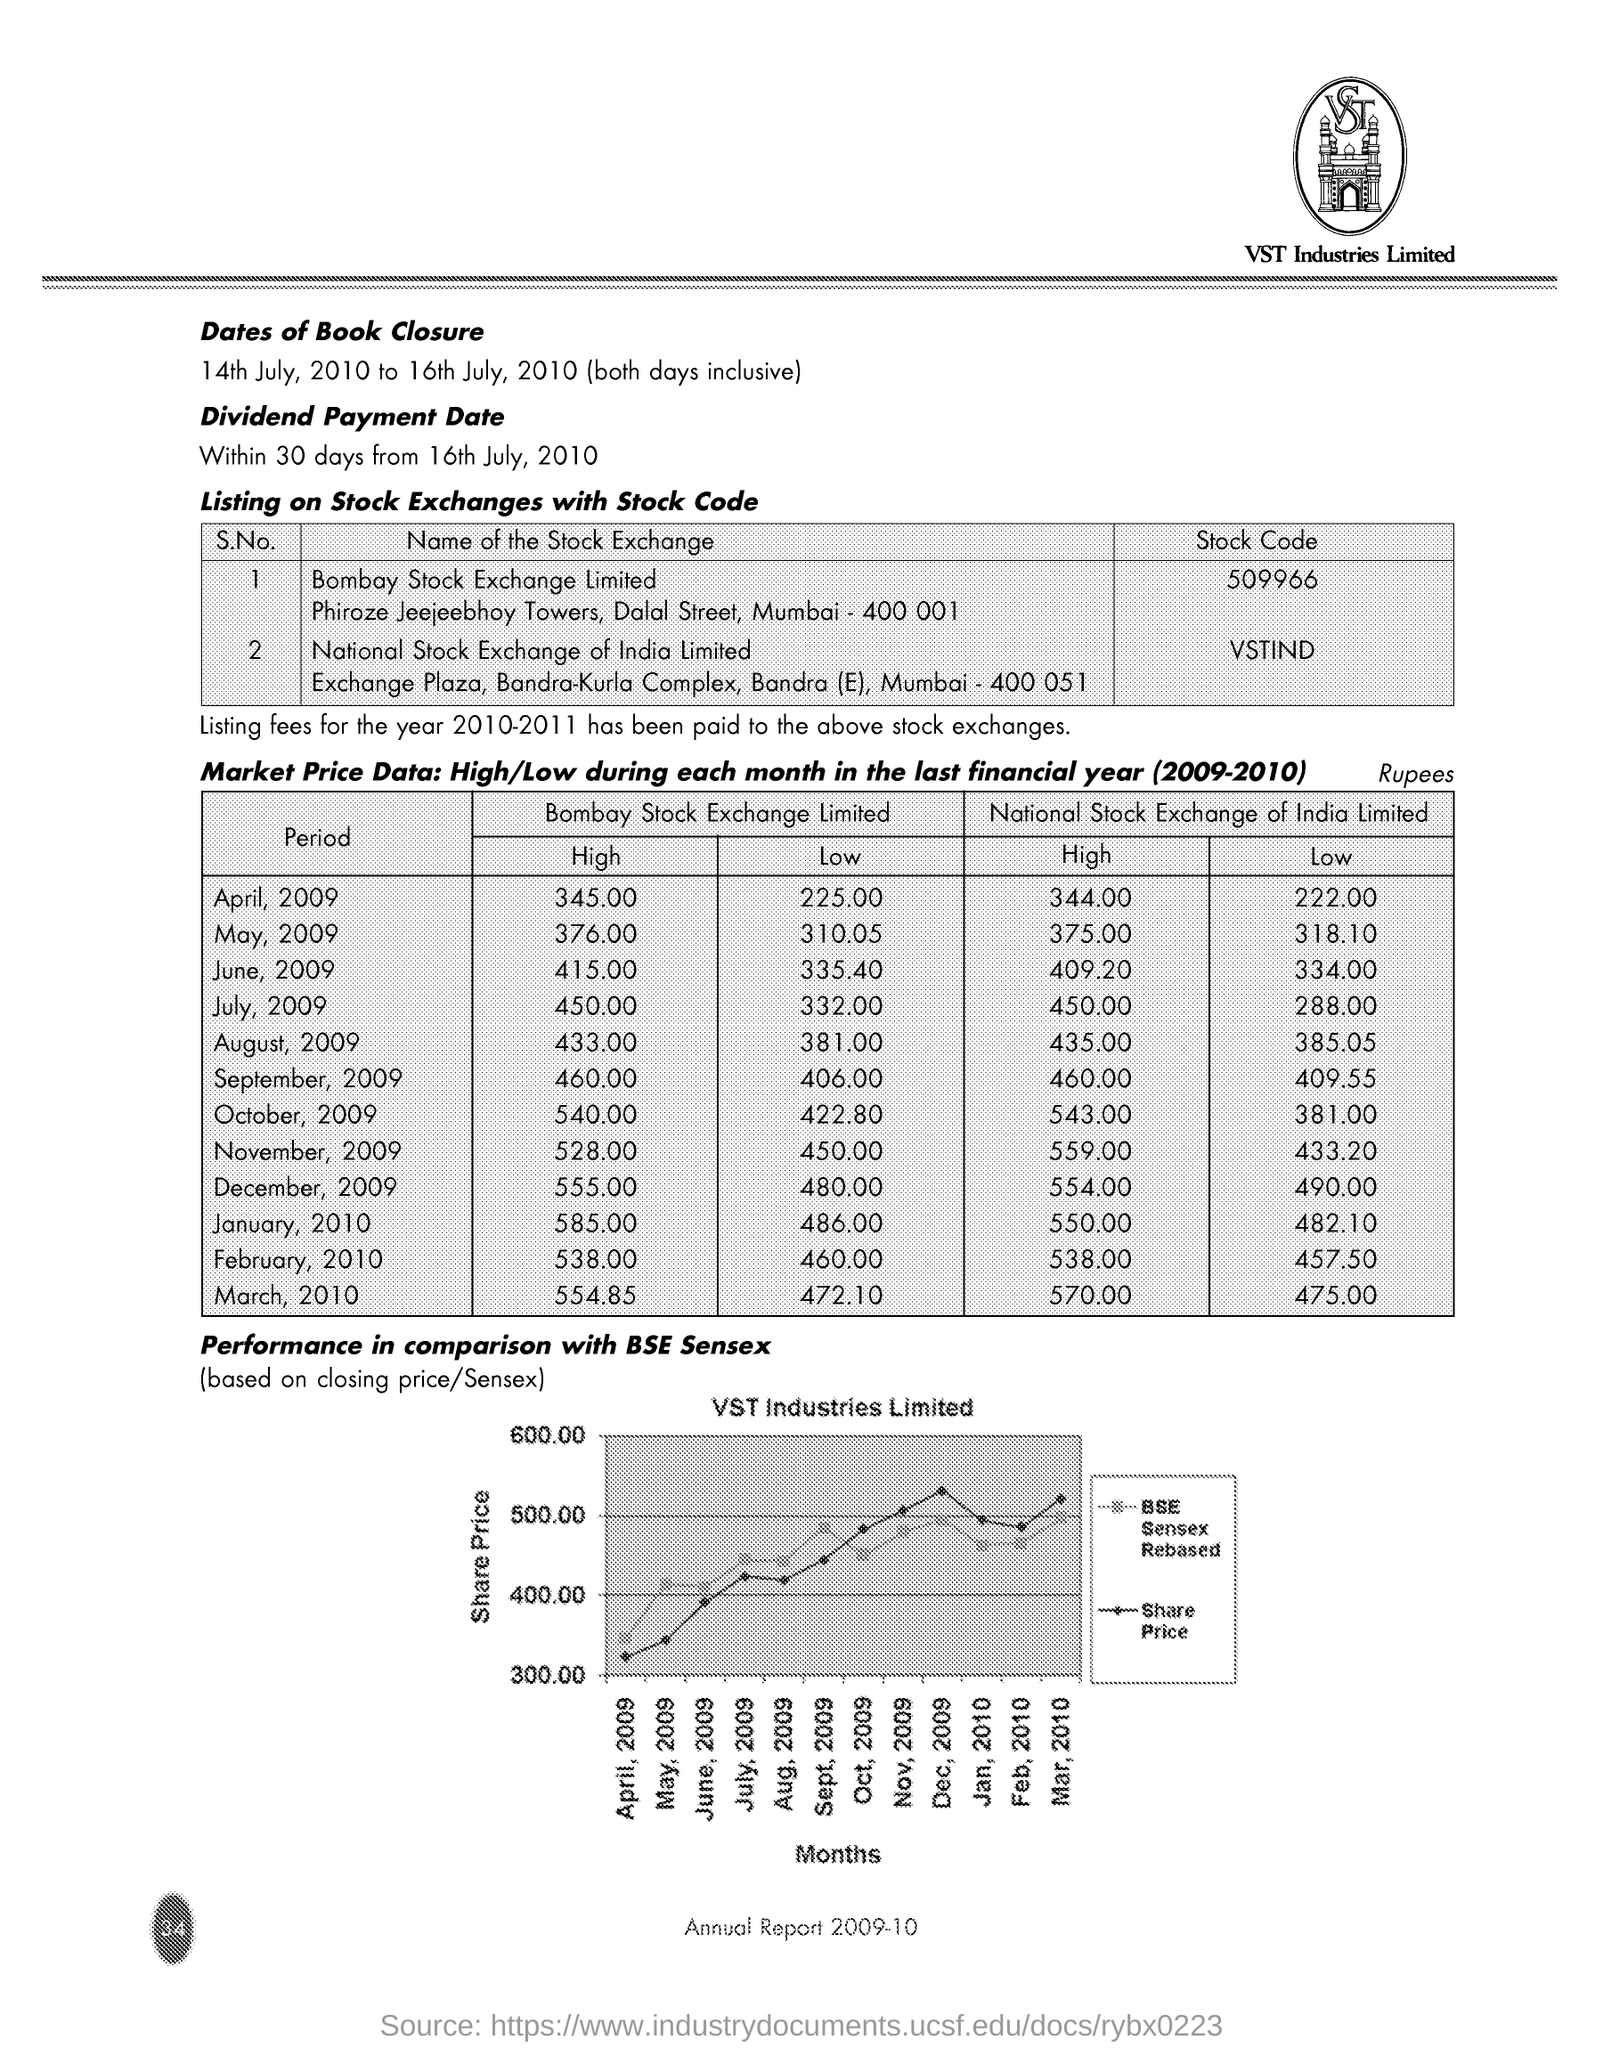What is the Dividend Payment Date mentioned in this document?
Your response must be concise. Within 30 days from 16th July, 2010. Which company is mentioned in the header of the document?
Ensure brevity in your answer.  VST Industries Limited. What is the Stock Code of company's shares listed on Bombay Stock Exchange Limited?
Ensure brevity in your answer.  509966. What is the Stock Code of company's shares listed on National Stock Exchange of India Limited ?
Your answer should be compact. VSTIND. What is the highest Market share price(Rs.) on Bombay Stock Exchange in April 2009 for the financial year 2009-10?
Your answer should be compact. 345.00. What is the Lowest Market share price(Rs.) on Bombay Stock Exchange in August 2009 for the financial year 2009-10?
Offer a terse response. 381. What is the highest Market share price(Rs.) on National Stock Exchange of India Limited in March 2010 for the financial year 2009-10?
Ensure brevity in your answer.  570. What is the lowest Market share price(Rs.) on National Stock Exchange of India Limited in March 2010 for the financial year 2009-10?
Keep it short and to the point. 475. 